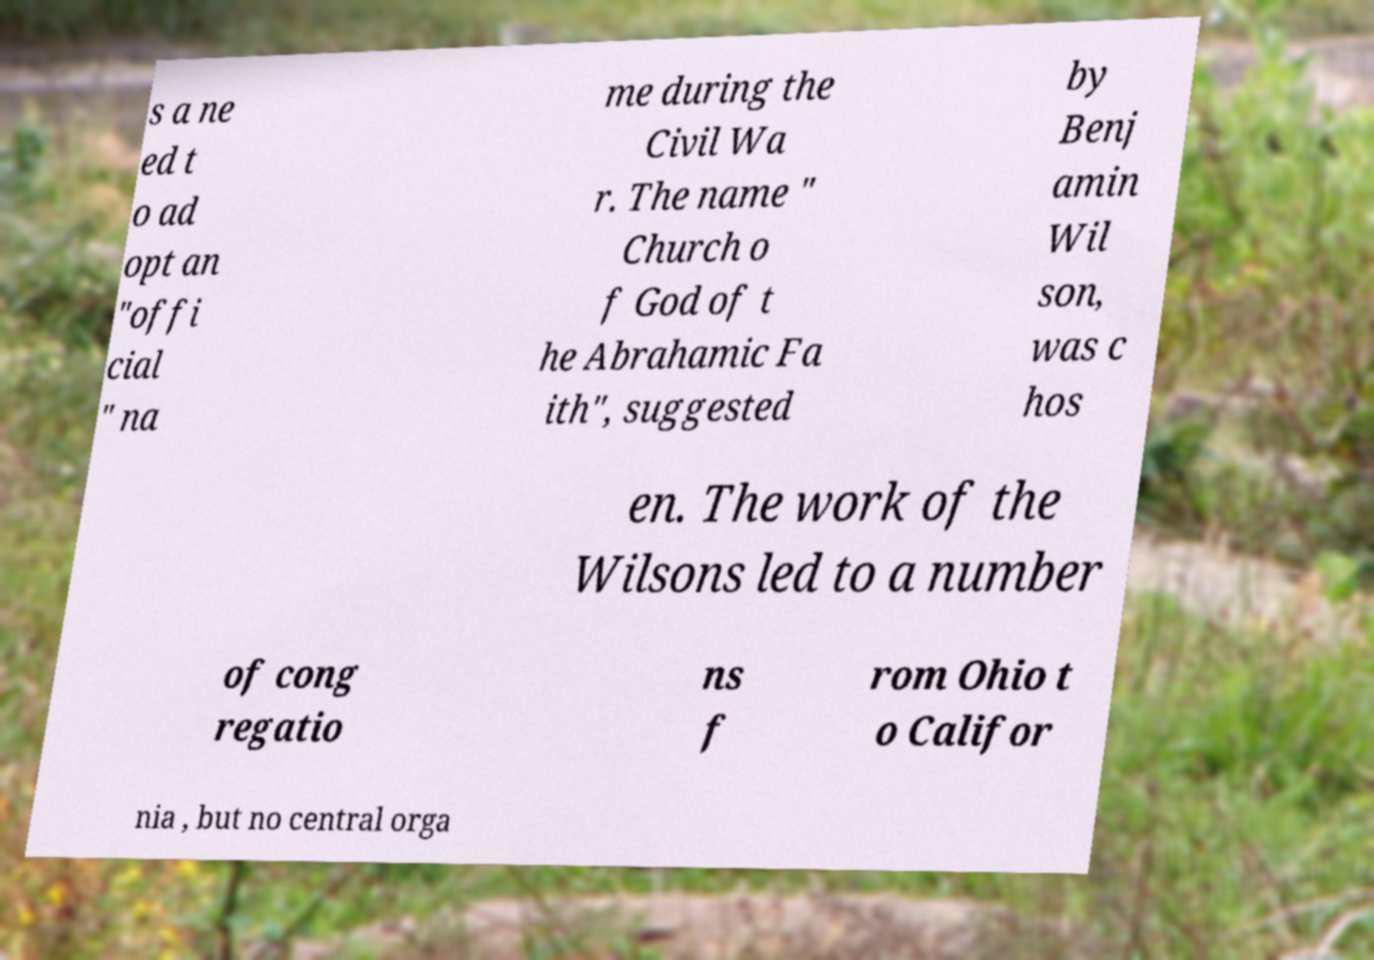Can you accurately transcribe the text from the provided image for me? s a ne ed t o ad opt an "offi cial " na me during the Civil Wa r. The name " Church o f God of t he Abrahamic Fa ith", suggested by Benj amin Wil son, was c hos en. The work of the Wilsons led to a number of cong regatio ns f rom Ohio t o Califor nia , but no central orga 